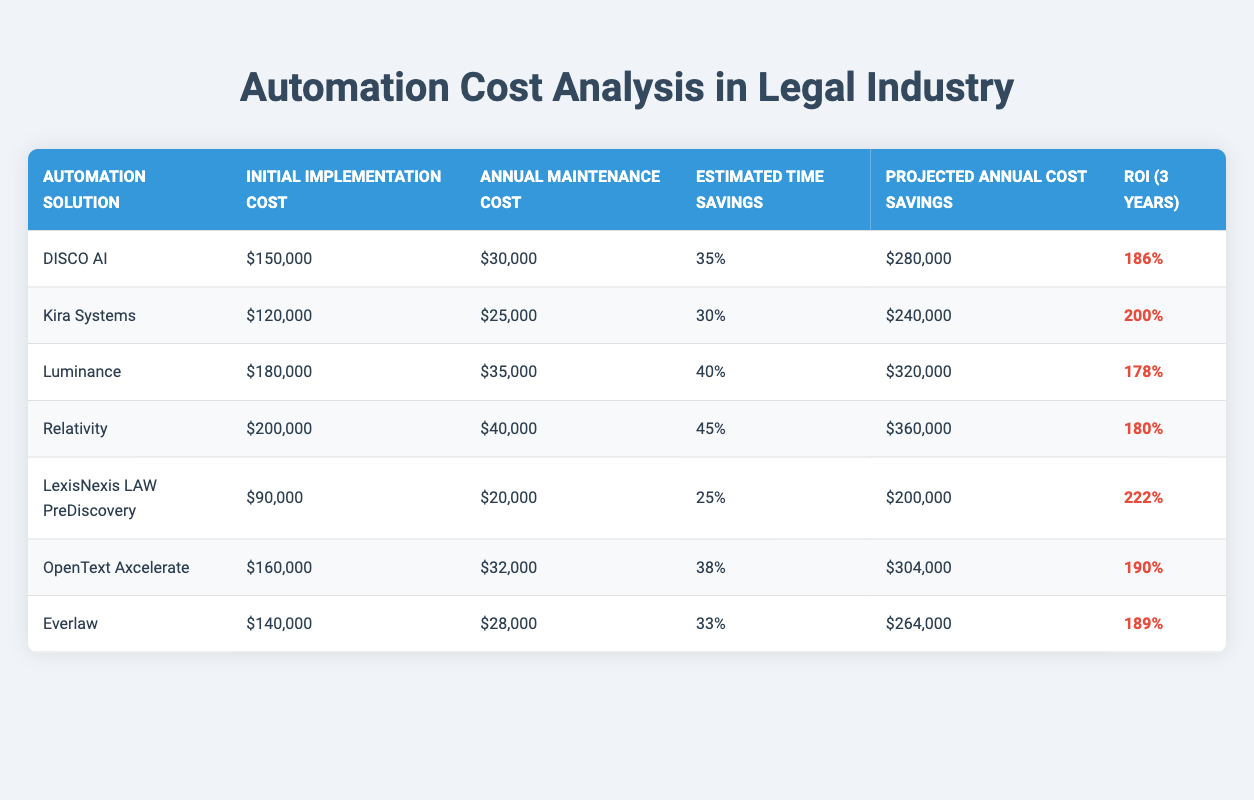What is the initial implementation cost of Kira Systems? The table lists Kira Systems under the "Automation Solution" column. In the same row, the corresponding value under the "Initial Implementation Cost" column is $120,000.
Answer: $120,000 Which automation solution has the highest projected annual cost savings? By examining the "Projected Annual Cost Savings" column, the highest value is $360,000, which corresponds to the Relativity solution.
Answer: Relativity What is the average annual maintenance cost of all the automation solutions listed? To calculate the average annual maintenance cost, we sum the maintenance costs: $30,000 + $25,000 + $35,000 + $40,000 + $20,000 + $32,000 + $28,000 = $210,000. Then, we divide by the number of solutions, which is 7: $210,000 / 7 = $30,000.
Answer: $30,000 Is the ROI of LexisNexis LAW PreDiscovery higher than that of OpenText Axcelerate? The ROI for LexisNexis LAW PreDiscovery is 222%, while for OpenText Axcelerate, it is 190%. Since 222% is greater than 190%, LexisNexis has a higher ROI.
Answer: Yes If an organization chooses the automation solution with the lowest initial implementation cost, what would their initial investment be? The table indicates that LexisNexis LAW PreDiscovery has the lowest initial implementation cost of $90,000.
Answer: $90,000 What is the total projected annual cost savings for the solutions where estimated time savings is greater than 35%? We identify the solutions with greater than 35% time savings: DISCO AI (35% - included), Luminance (40%), Relativity (45%), OpenText Axcelerate (38%), and Everlaw (33% - excluded). Thus, we sum the projected savings of: $280,000 + $320,000 + $360,000 + $304,000 = $1,264,000.
Answer: $1,264,000 Which solution has both the highest initial implementation cost and the highest annual maintenance cost? Reviewing both columns, Relativity is the solution with the highest initial implementation cost of $200,000 and the highest annual maintenance cost of $40,000.
Answer: Relativity Among all the solutions, which has the lowest estimated time savings percentage? In the "Estimated Time Savings" column, the lowest percentage is found in LexisNexis LAW PreDiscovery, which is 25%.
Answer: 25% 